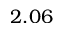Convert formula to latex. <formula><loc_0><loc_0><loc_500><loc_500>2 . 0 6</formula> 